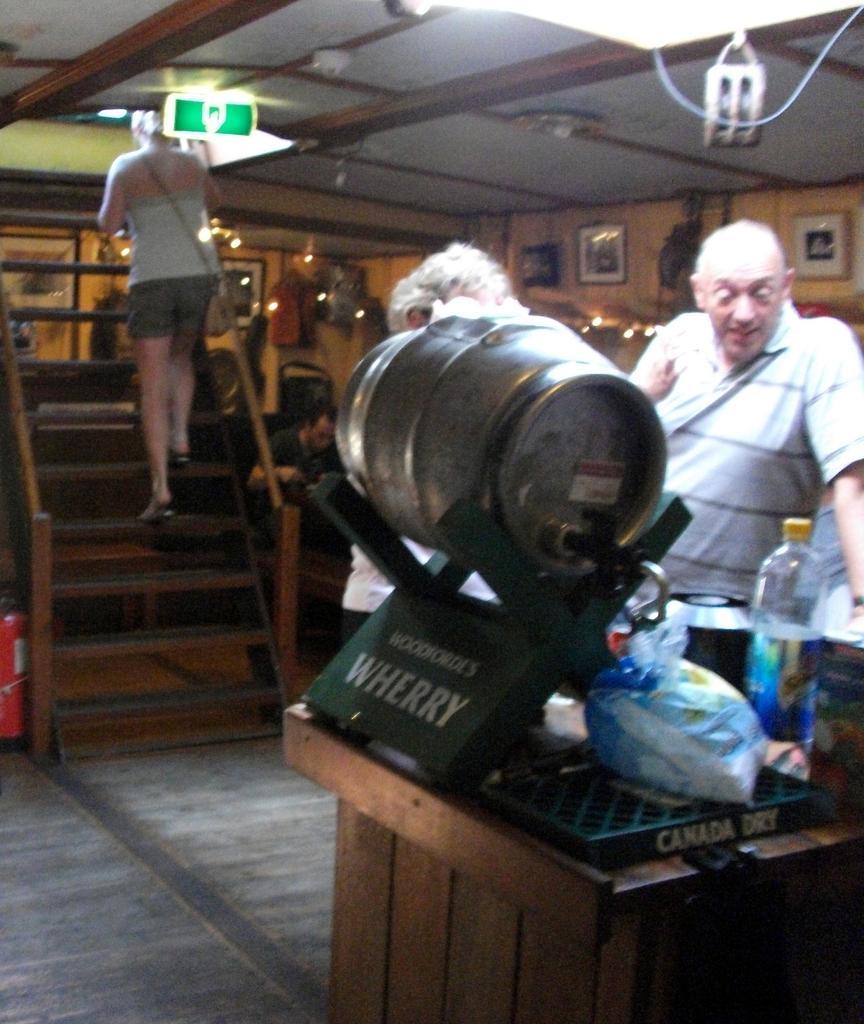Could you give a brief overview of what you see in this image? In the image there is a woman walking on steps in the back and on the right side there are two persons standing in front of table with bottles and barrels on it and on the background there are photographs and lights on the wall. 